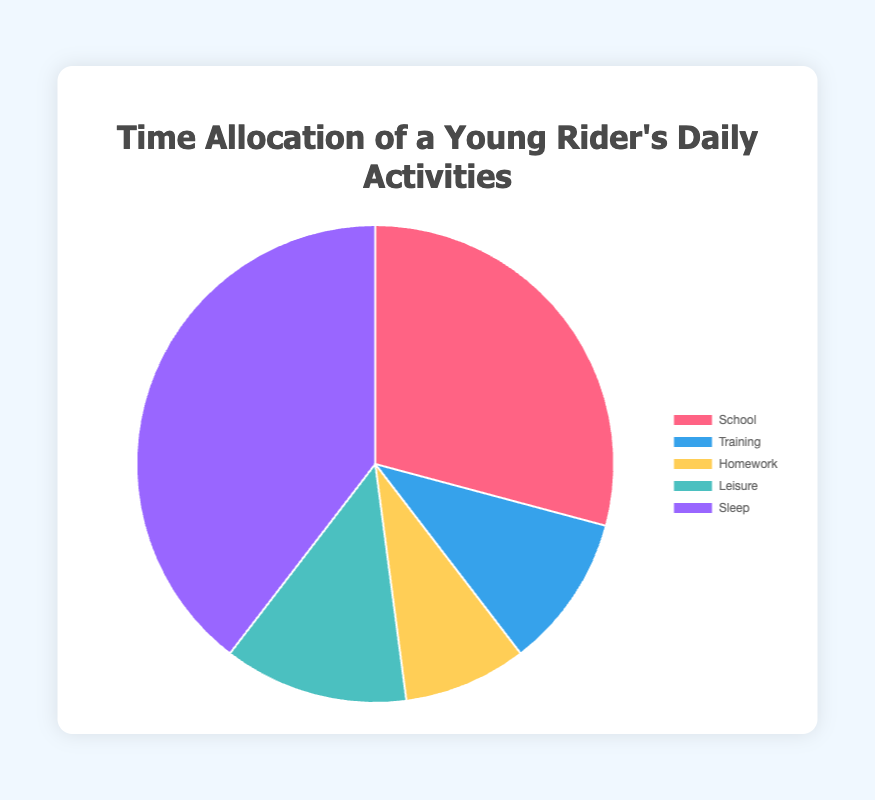What activity takes up the most time in a young rider's daily schedule? Sleep takes up the most time as it spans 9.5 hours.
Answer: Sleep Which two activities together use more than half of the day? Sleep (9.5 hours) and School (7 hours) together total 16.5 hours, which is more than half of a day (24 hours).
Answer: Sleep and School How many hours are dedicated to training and homework combined? Training is 2.5 hours and Homework is 2 hours. Together, they combine to 4.5 hours.
Answer: 4.5 What is the percentage of time spent on leisure out of the total daily hours? Leisure is 3 hours. The total hours in a day are 24. The percentage is (3/24) * 100% = 12.5%.
Answer: 12.5% Which activity uses less time: Training or Homework? Training uses 2.5 hours whereas Homework uses 2 hours. Homework uses less time.
Answer: Homework Is the time allocated for sleep and school combined more than 16 hours? Sleep is 9.5 hours and School is 7 hours. Together, they sum up to 16.5 hours, which is more than 16 hours.
Answer: Yes What color represents the activity with the least amount of time allocated? Homework, which is allocated 2 hours, is represented by yellow.
Answer: Yellow How much more time is spent on training compared to leisure activities? Training is 2.5 hours, and Leisure is 3 hours. Leisure activities actually take 0.5 hours more than training.
Answer: 0.5 hours less What percentage of the total daily activities is allocated to school? School takes 7 hours out of a total of 24 hours. The percentage is (7/24) * 100% ≈ 29.17%.
Answer: 29.17% 